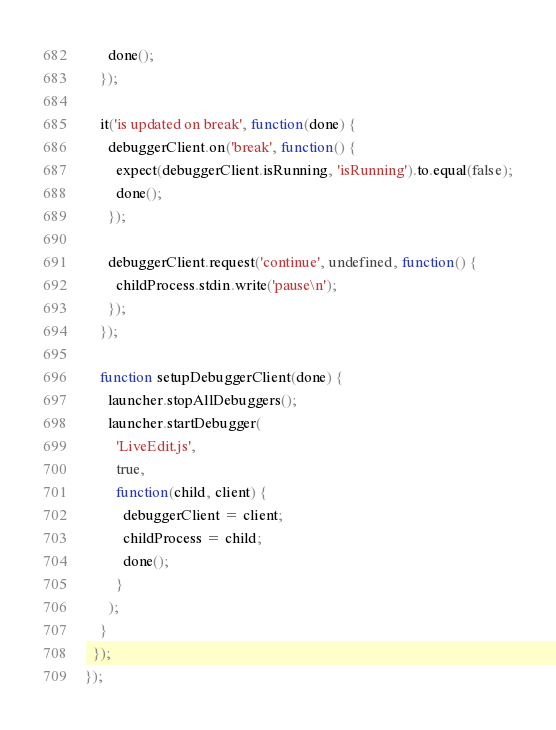<code> <loc_0><loc_0><loc_500><loc_500><_JavaScript_>      done();
    });

    it('is updated on break', function(done) {
      debuggerClient.on('break', function() {
        expect(debuggerClient.isRunning, 'isRunning').to.equal(false);
        done();
      });

      debuggerClient.request('continue', undefined, function() {
        childProcess.stdin.write('pause\n');
      });
    });

    function setupDebuggerClient(done) {
      launcher.stopAllDebuggers();
      launcher.startDebugger(
        'LiveEdit.js',
        true,
        function(child, client) {
          debuggerClient = client;
          childProcess = child;
          done();
        }
      );
    }
  });
});
</code> 